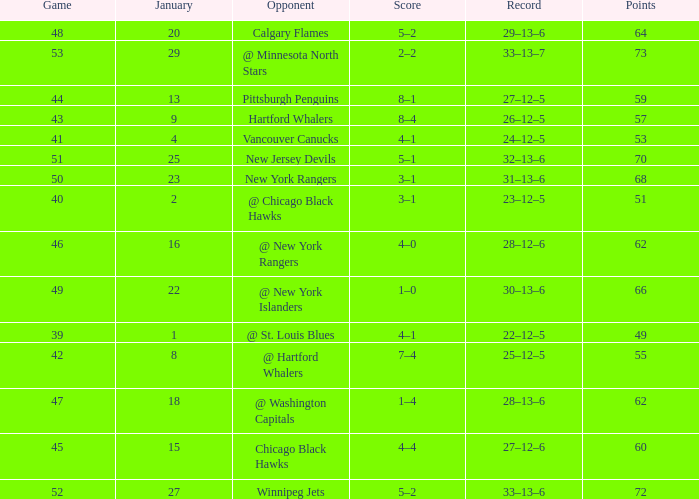Which January has a Score of 7–4, and a Game smaller than 42? None. 